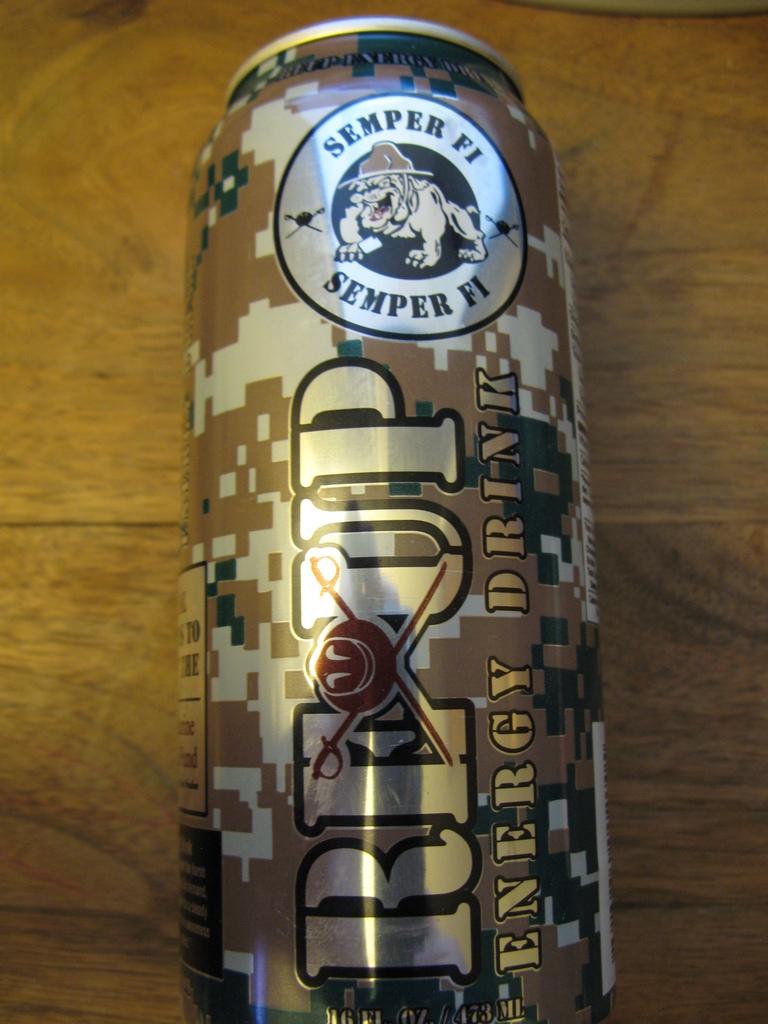What type of a beverage is in this can?
Provide a succinct answer. Energy drink. What is the slogan?
Offer a terse response. Semper fi. 